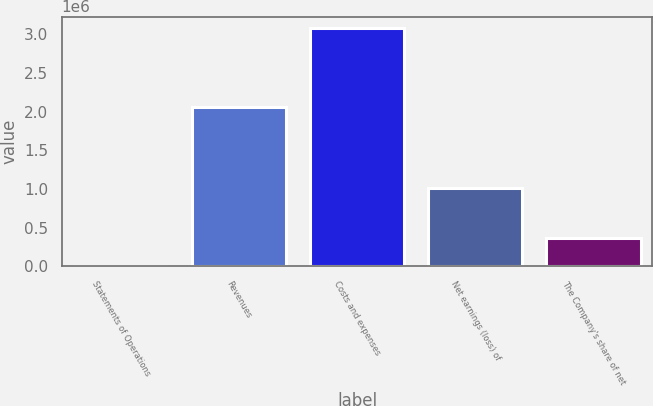<chart> <loc_0><loc_0><loc_500><loc_500><bar_chart><fcel>Statements of Operations<fcel>Revenues<fcel>Costs and expenses<fcel>Net earnings (loss) of<fcel>The Company's share of net<nl><fcel>2007<fcel>2.06028e+06<fcel>3.0757e+06<fcel>1.01542e+06<fcel>362899<nl></chart> 